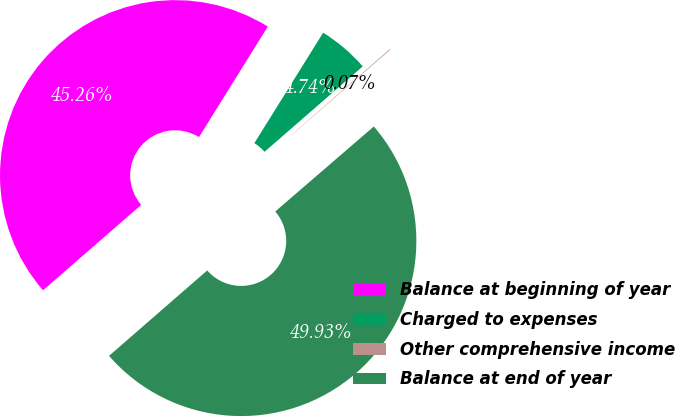Convert chart to OTSL. <chart><loc_0><loc_0><loc_500><loc_500><pie_chart><fcel>Balance at beginning of year<fcel>Charged to expenses<fcel>Other comprehensive income<fcel>Balance at end of year<nl><fcel>45.26%<fcel>4.74%<fcel>0.07%<fcel>49.93%<nl></chart> 